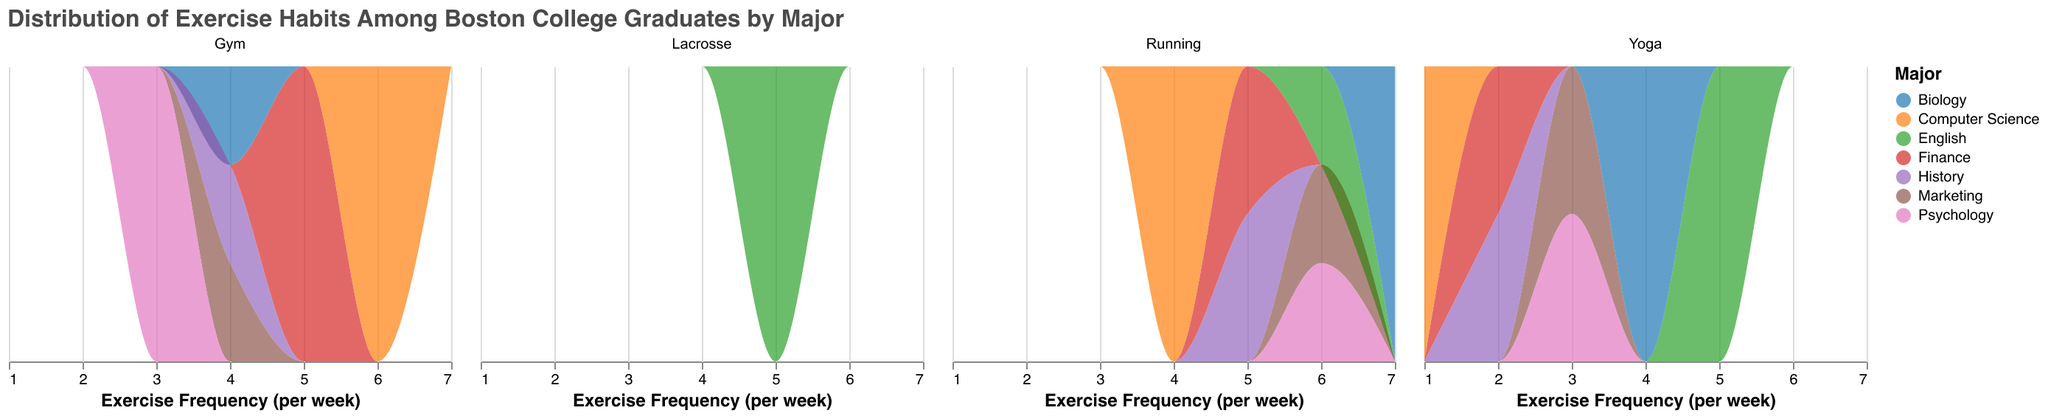What's the title of the figure? The title is usually placed at the top of the figure and it provides a brief description of what the figure is about.
Answer: Distribution of Exercise Habits Among Boston College Graduates by Major How often do English majors do Yoga per week? The density plot represents the exercise habits for each major. By checking the part of the plot labeled "English" under the "Yoga" facet, you can see the frequency per week.
Answer: 5 times per week Which major has students who run the most frequently? Look at the density plot under the "Running" facet. The major with the highest frequency (most right on the x-axis) is Biology.
Answer: Biology What's the average frequency of exercise per week for Psychology majors? To find the average, you need to sum up the frequency values for all exercise habits of Psychology majors: (Running: 6, Yoga: 3, Gym: 3), then divide by the number of activities.
Answer: (6+3+3)/3 = 4 times per week Which major has the most diverse set of exercise habits? By examining the different exercise habits listed under each major and their frequency spread, you can identify the major with the most varied exercise habits. English majors participate in Lacrosse, Yoga, and Running.
Answer: English Do Finance and History majors have similar exercise habits? Compare the density plots for Finance and History under each exercise habit. If their distributions and frequencies are similar, they have similar exercise habits. Both have similar running and gym habits, but their yoga habits differ slightly.
Answer: Yes, similar but with slight differences in Yoga Which exercise habit among all majors has the highest frequency per week? Check the density plots to find the exercise habit with the highest frequency value on the x-axis across all majors.
Answer: Biology majors who run (7 times per week) How often do Computer Science majors go to the gym? The density plot under the "Gym" facet for Computer Science majors shows their exercise frequency.
Answer: 6 times per week 